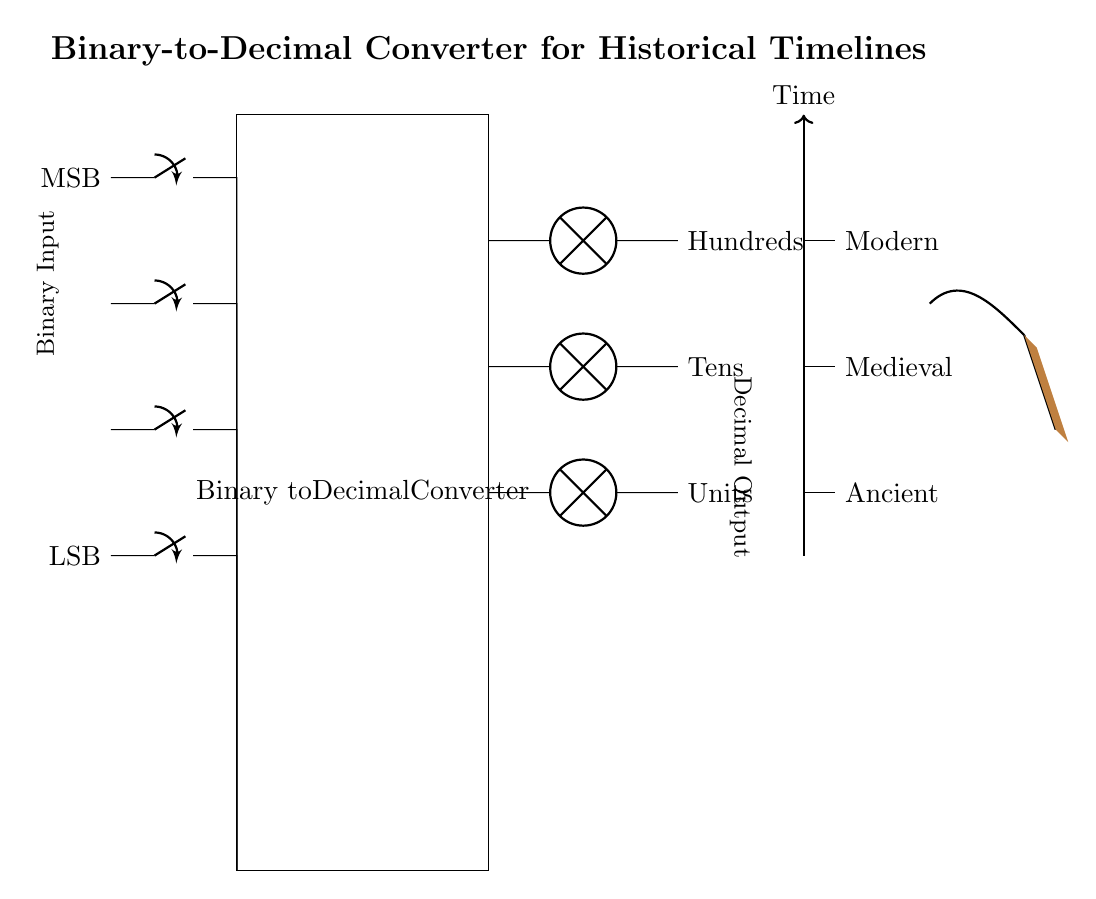What is the function of the circuit? The primary function of this circuit is to convert binary values into decimal equivalents. The diagram indicates a binary-to-decimal converter.
Answer: Binary-to-Decimal Converter How many binary switches are present? There are four binary switches shown in the circuit diagram, representing LSB to MSB positions.
Answer: Four What type of components are used for displaying output? The output is displayed using lamps, which represent the decimal values of units, tens, and hundreds.
Answer: Lamps What does the thick arrow indicate? The thick arrow represents the flow of time, suggesting a timeline from ancient to modern periods.
Answer: Time Where is the ancient timeline depicted? The ancient timeline is represented at the lowest position on the time reference line.
Answer: Bottom (Ancient) How are the historical periods categorized in the circuit? The historical periods are categorized into three sections: Ancient, Medieval, and Modern, indicated by horizontal lines on the time axis.
Answer: Ancient, Medieval, Modern What artistic element is incorporated in the design? An artistic touch is added with a representation of a paintbrush, showcasing the painter's perspective in the design.
Answer: Paintbrush 